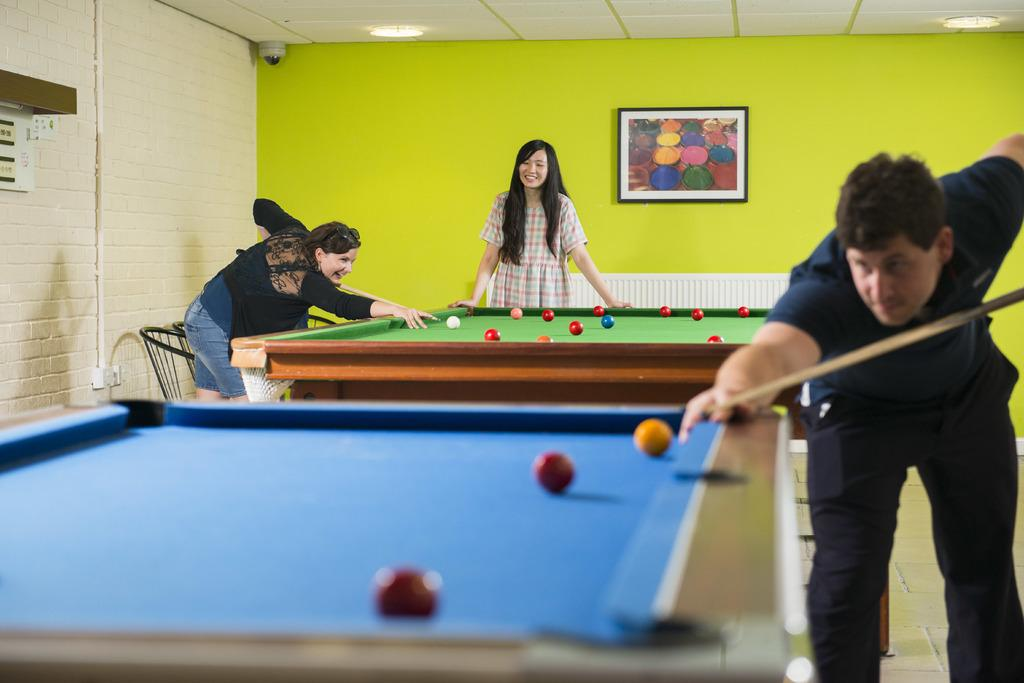Who is present in the image? There is a man and a woman in the image. What activity are the man and woman engaged in? The man and woman are playing billiards. What can be seen in the background of the image? There is a photo frame in the background of the image. What type of fruit is being served for breakfast in the image? There is no mention of breakfast or fruit in the image; it features a man and a woman playing billiards with a photo frame in the background. 